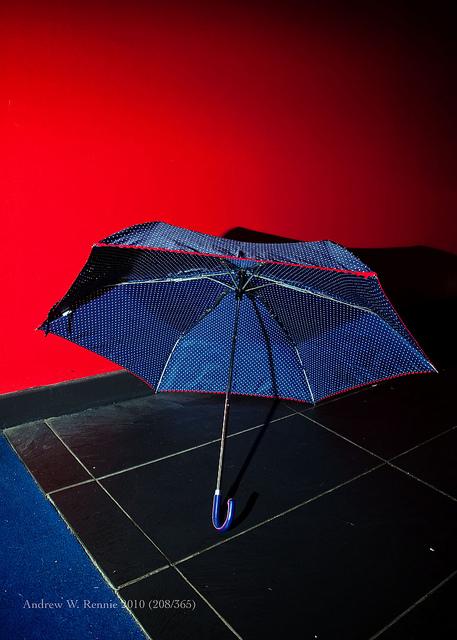See any ribbons?
Short answer required. No. What is the handle of the umbrella made with?
Keep it brief. Plastic. Does the umbrella match the walls and floor?
Answer briefly. Yes. Is the open umbrella on it's side?
Write a very short answer. Yes. What color is the wall?
Write a very short answer. Red. 